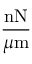<formula> <loc_0><loc_0><loc_500><loc_500>\frac { n N } { \mu m }</formula> 